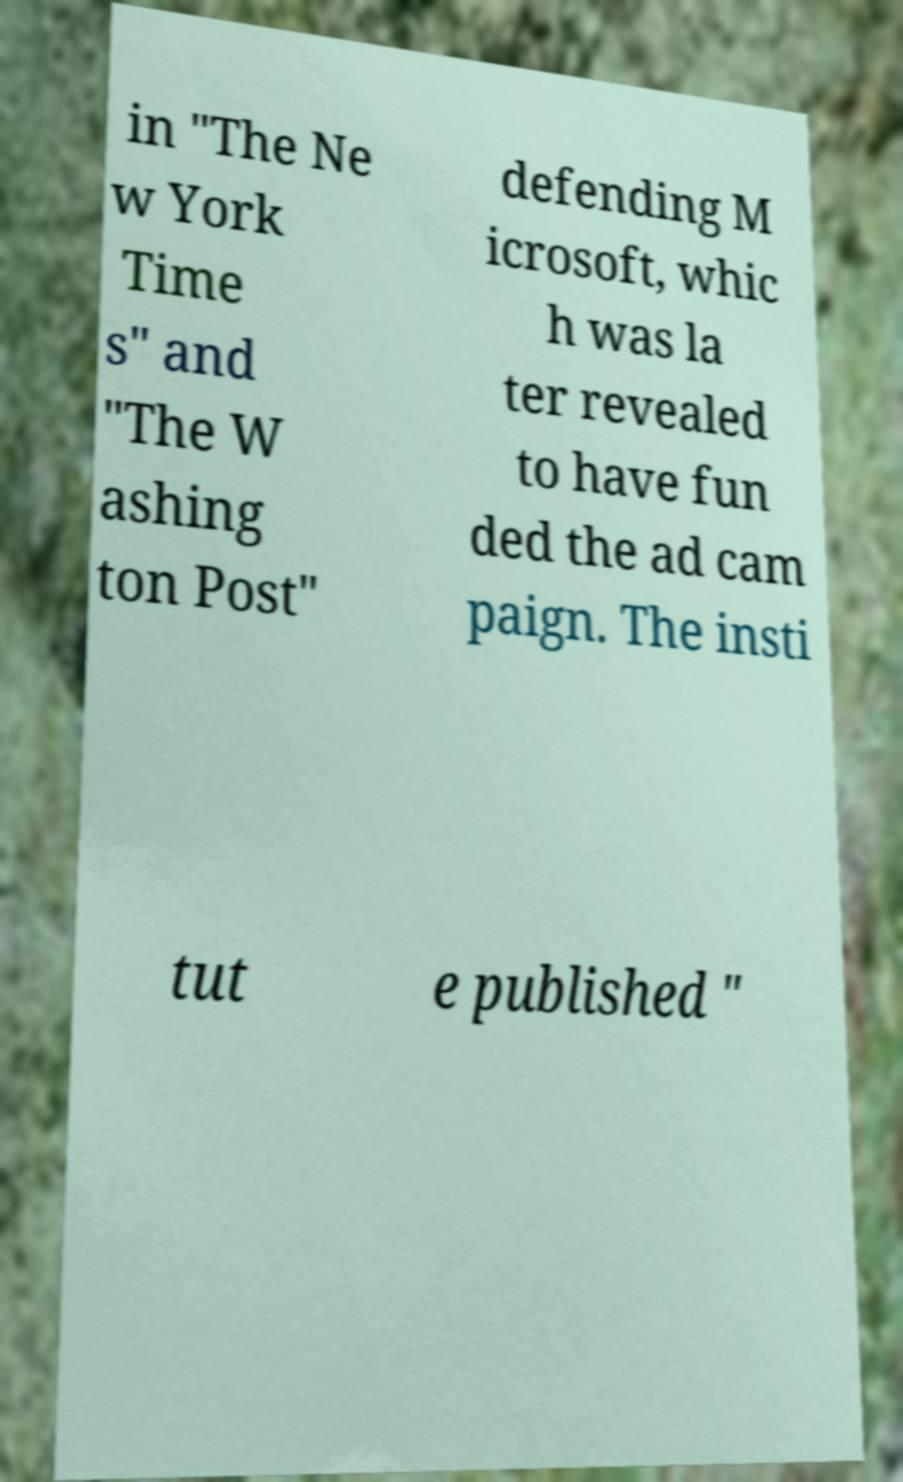For documentation purposes, I need the text within this image transcribed. Could you provide that? in "The Ne w York Time s" and "The W ashing ton Post" defending M icrosoft, whic h was la ter revealed to have fun ded the ad cam paign. The insti tut e published " 